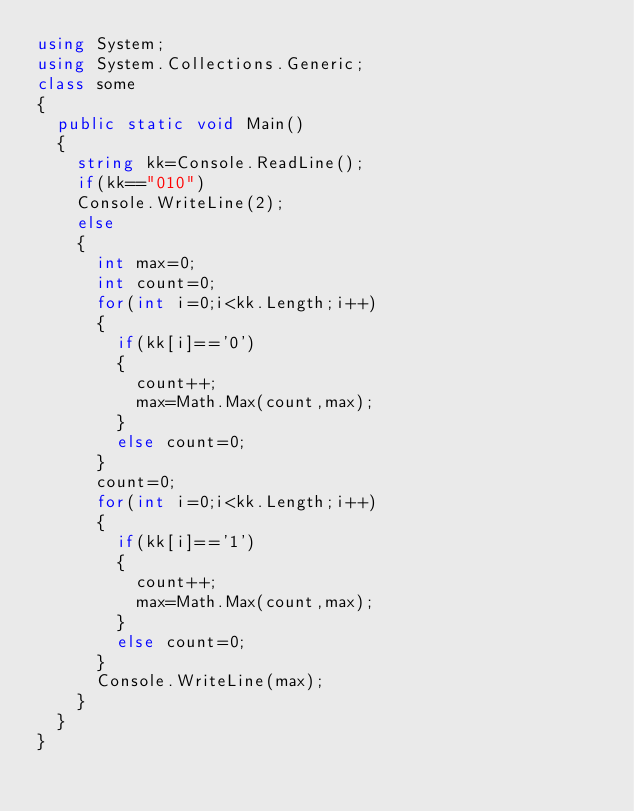Convert code to text. <code><loc_0><loc_0><loc_500><loc_500><_C#_>using System;
using System.Collections.Generic;
class some
{
	public static void Main()
	{
		string kk=Console.ReadLine();
		if(kk=="010")
		Console.WriteLine(2);
		else
		{
			int max=0;
			int count=0;
			for(int i=0;i<kk.Length;i++)
			{
				if(kk[i]=='0')
				{
					count++;		
					max=Math.Max(count,max);
				}
				else count=0;
			}
			count=0;
			for(int i=0;i<kk.Length;i++)
			{
				if(kk[i]=='1')
				{
					count++;		
					max=Math.Max(count,max);
				}
				else count=0;
			}
			Console.WriteLine(max);
		}
	}
}</code> 